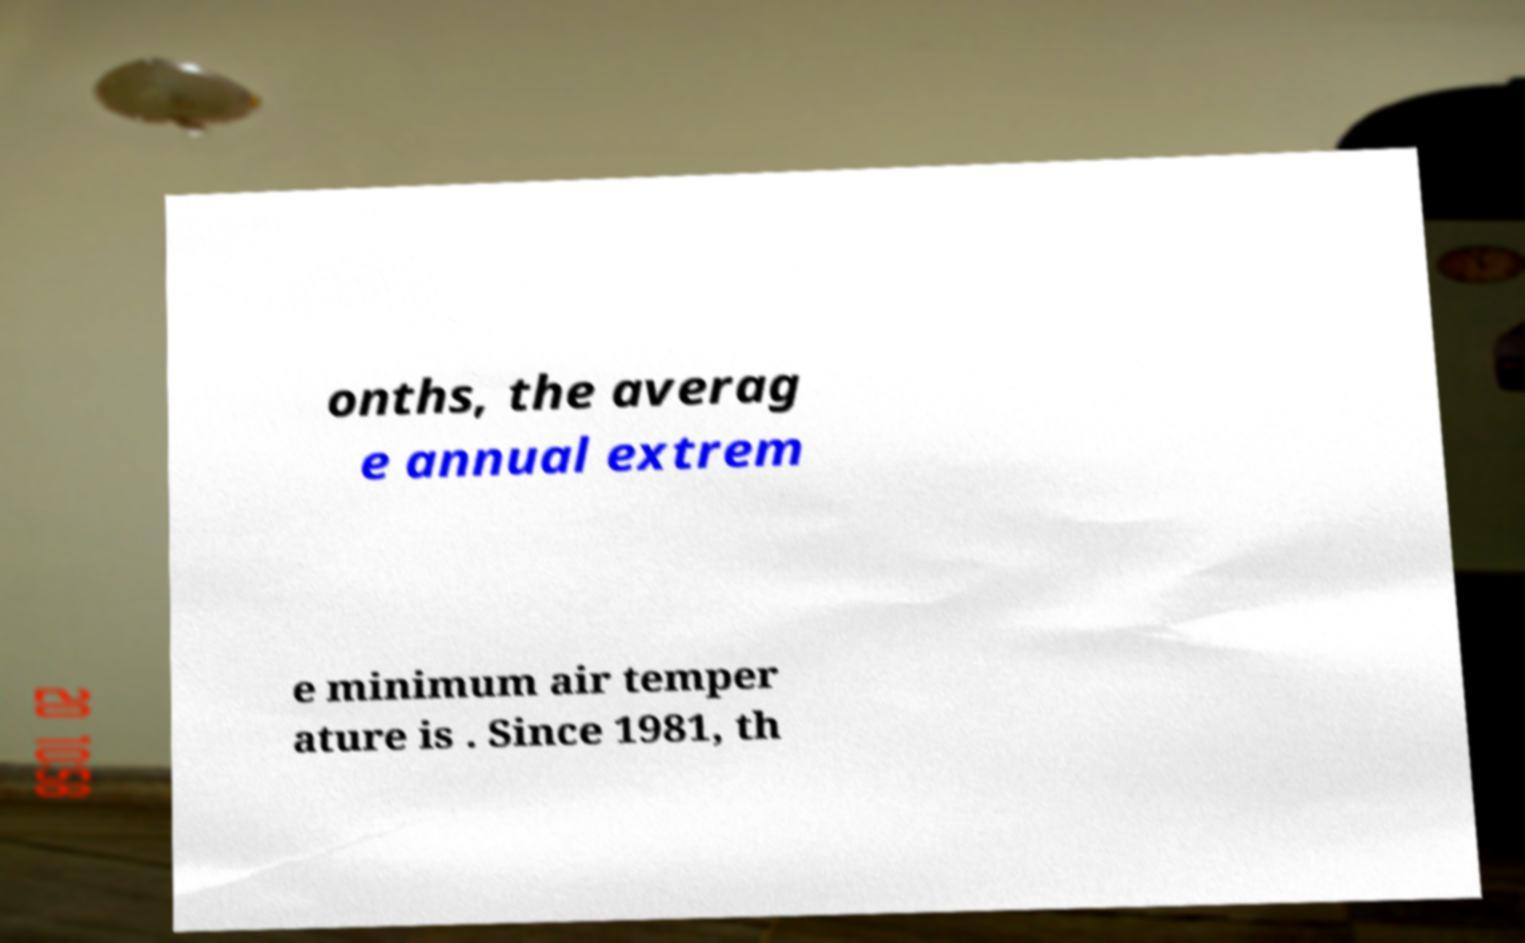There's text embedded in this image that I need extracted. Can you transcribe it verbatim? onths, the averag e annual extrem e minimum air temper ature is . Since 1981, th 